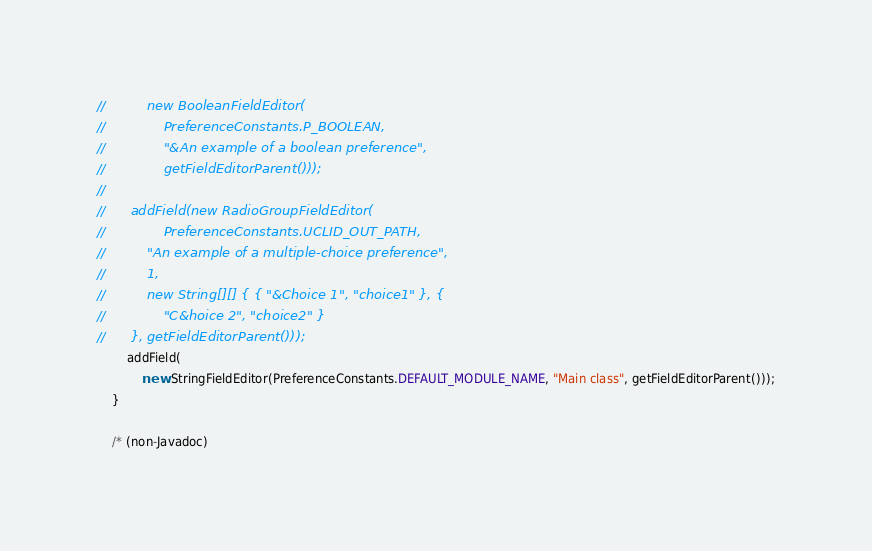<code> <loc_0><loc_0><loc_500><loc_500><_Java_>//			new BooleanFieldEditor(
//				PreferenceConstants.P_BOOLEAN,
//				"&An example of a boolean preference",
//				getFieldEditorParent()));
//
//		addField(new RadioGroupFieldEditor(
//				PreferenceConstants.UCLID_OUT_PATH,
//			"An example of a multiple-choice preference",
//			1,
//			new String[][] { { "&Choice 1", "choice1" }, {
//				"C&hoice 2", "choice2" }
//		}, getFieldEditorParent()));
		addField(
			new StringFieldEditor(PreferenceConstants.DEFAULT_MODULE_NAME, "Main class", getFieldEditorParent()));
	}

	/* (non-Javadoc)</code> 